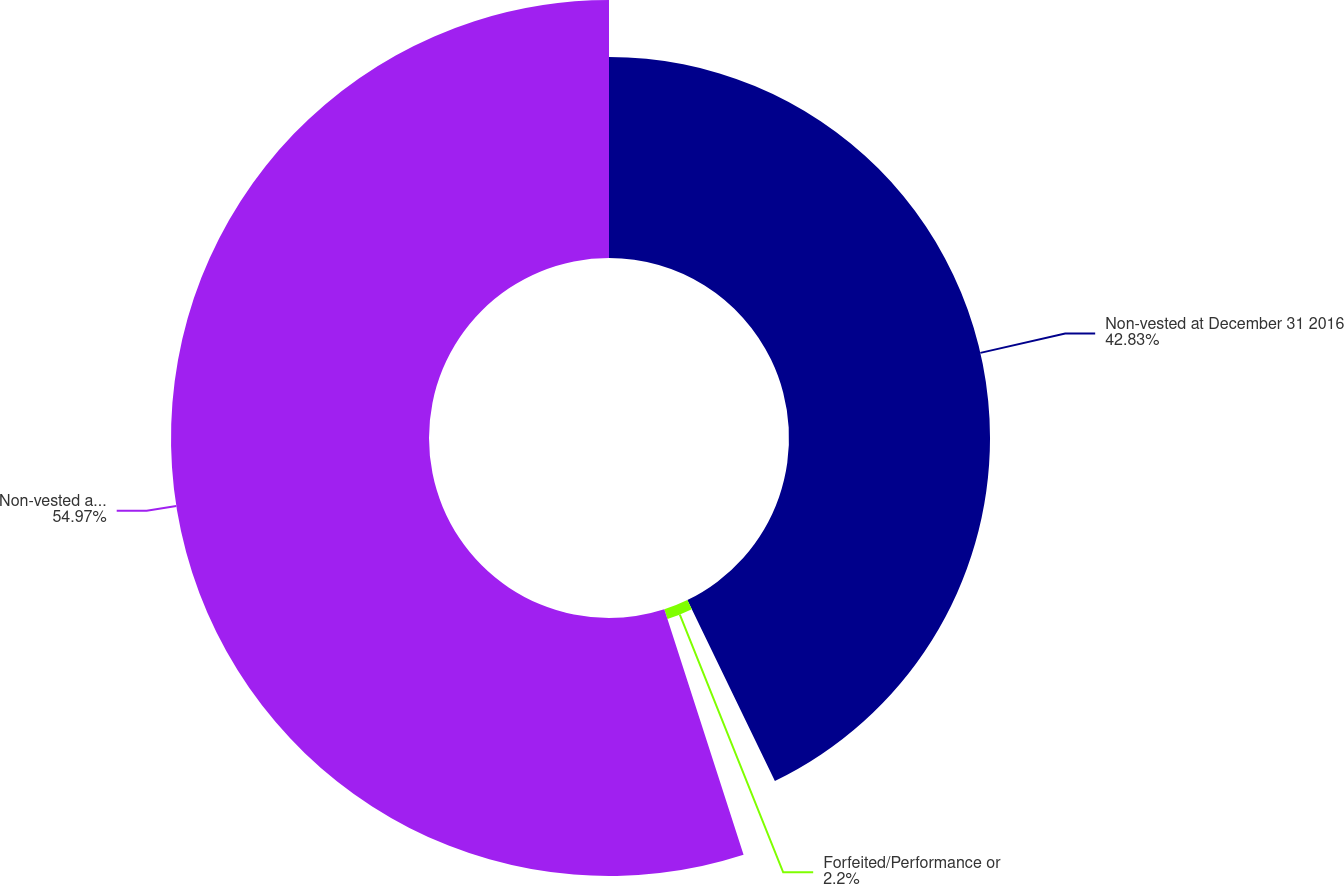Convert chart to OTSL. <chart><loc_0><loc_0><loc_500><loc_500><pie_chart><fcel>Non-vested at December 31 2016<fcel>Forfeited/Performance or<fcel>Non-vested at December 31 2017<nl><fcel>42.83%<fcel>2.2%<fcel>54.97%<nl></chart> 